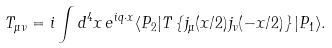Convert formula to latex. <formula><loc_0><loc_0><loc_500><loc_500>T _ { \mu \nu } = i \int d ^ { 4 } x \, e ^ { i q \cdot x } \langle P _ { 2 } | T \left \{ j _ { \mu } ( x / 2 ) j _ { \nu } ( - x / 2 ) \right \} | P _ { 1 } \rangle .</formula> 